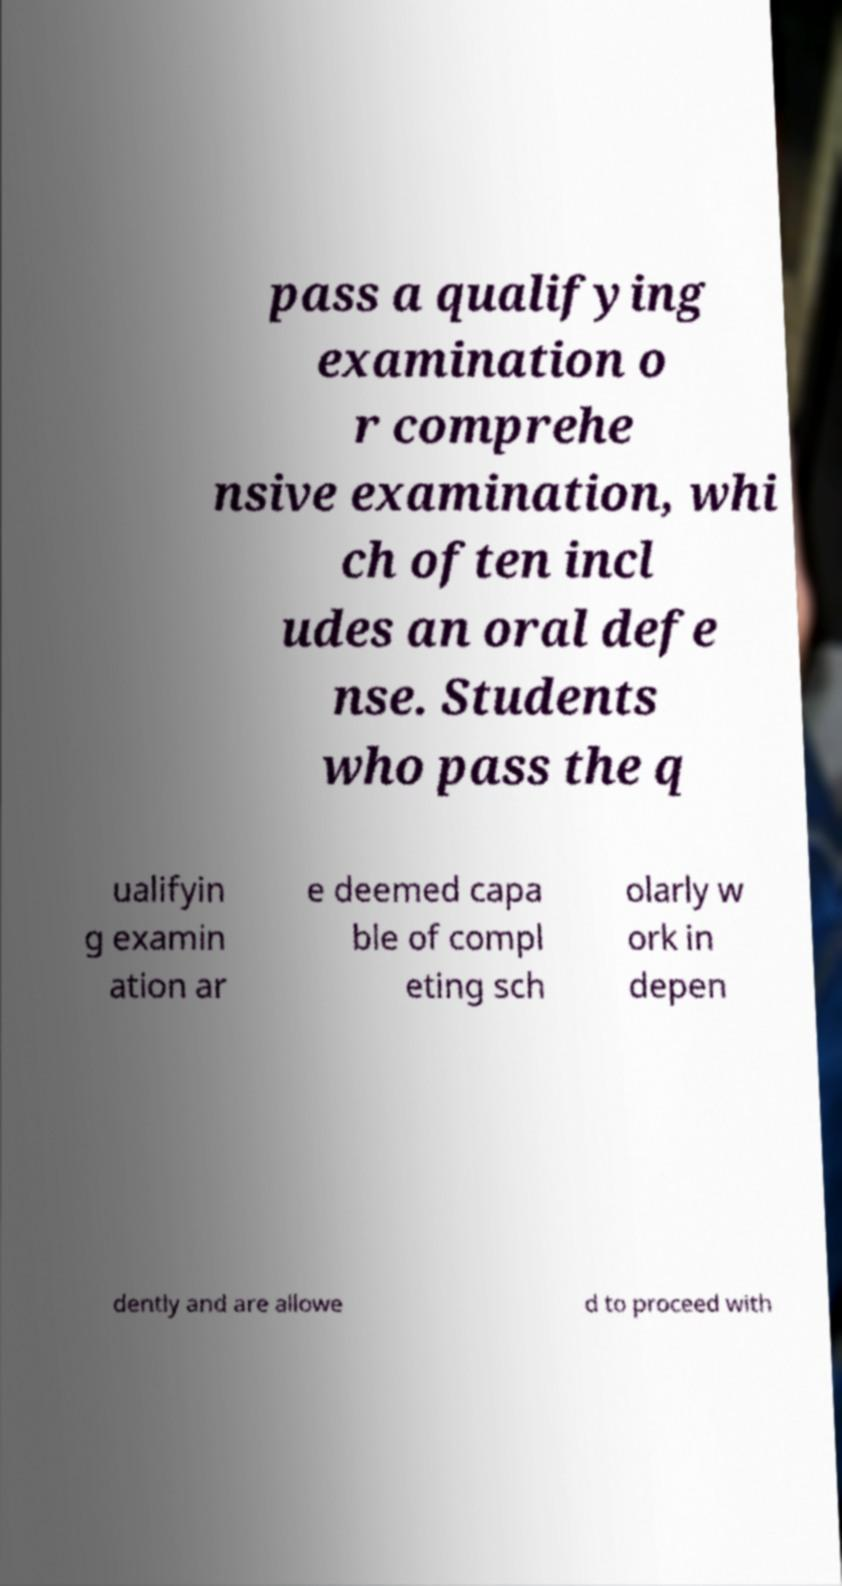Can you accurately transcribe the text from the provided image for me? pass a qualifying examination o r comprehe nsive examination, whi ch often incl udes an oral defe nse. Students who pass the q ualifyin g examin ation ar e deemed capa ble of compl eting sch olarly w ork in depen dently and are allowe d to proceed with 